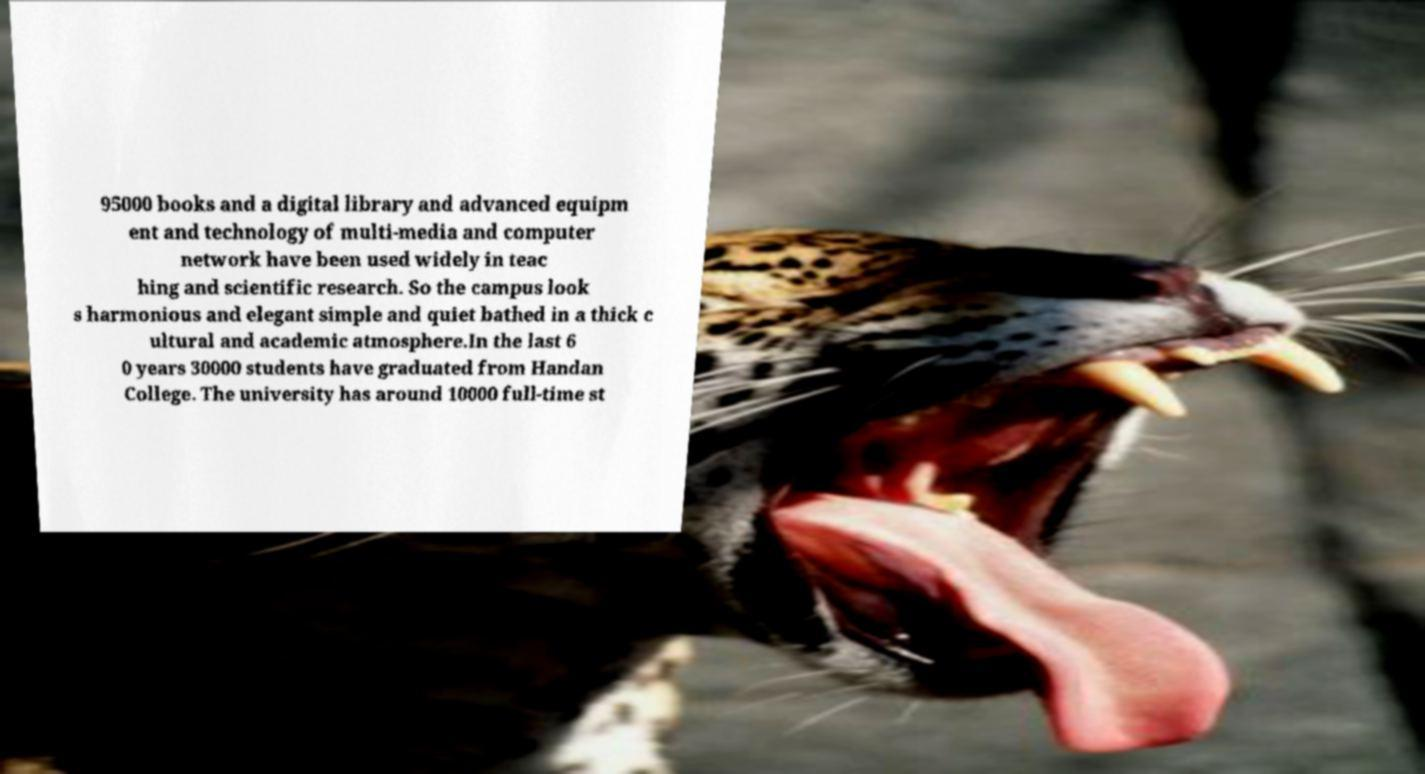I need the written content from this picture converted into text. Can you do that? 95000 books and a digital library and advanced equipm ent and technology of multi-media and computer network have been used widely in teac hing and scientific research. So the campus look s harmonious and elegant simple and quiet bathed in a thick c ultural and academic atmosphere.In the last 6 0 years 30000 students have graduated from Handan College. The university has around 10000 full-time st 